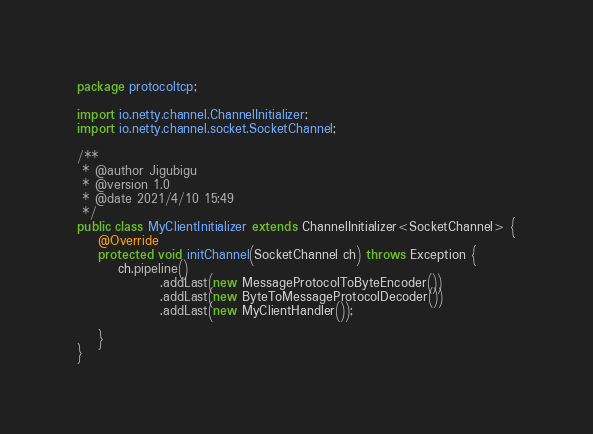Convert code to text. <code><loc_0><loc_0><loc_500><loc_500><_Java_>package protocoltcp;

import io.netty.channel.ChannelInitializer;
import io.netty.channel.socket.SocketChannel;

/**
 * @author Jigubigu
 * @version 1.0
 * @date 2021/4/10 15:49
 */
public class MyClientInitializer extends ChannelInitializer<SocketChannel> {
    @Override
    protected void initChannel(SocketChannel ch) throws Exception {
        ch.pipeline()
                .addLast(new MessageProtocolToByteEncoder())
                .addLast(new ByteToMessageProtocolDecoder())
                .addLast(new MyClientHandler());

    }
}
</code> 